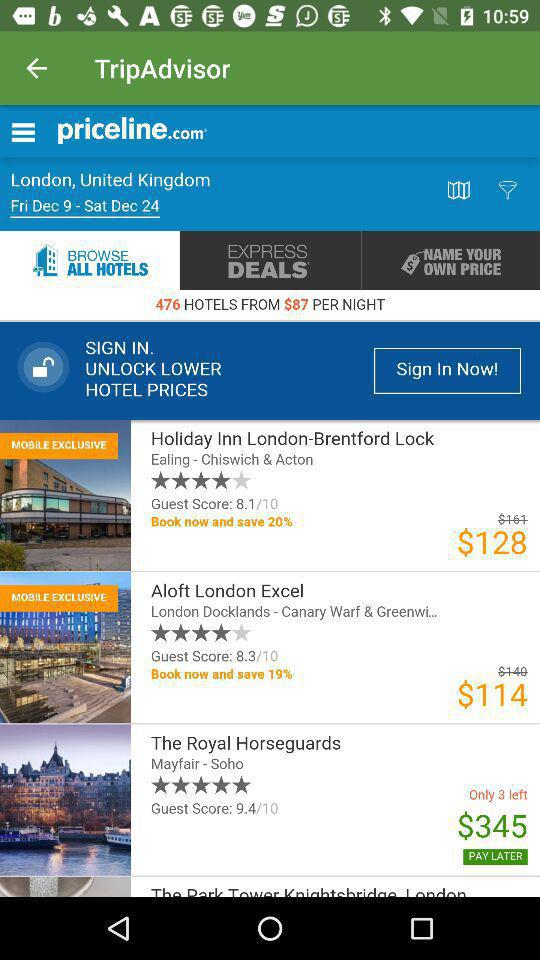How many hotels have a guest score of 9.4 or higher?
Answer the question using a single word or phrase. 1 